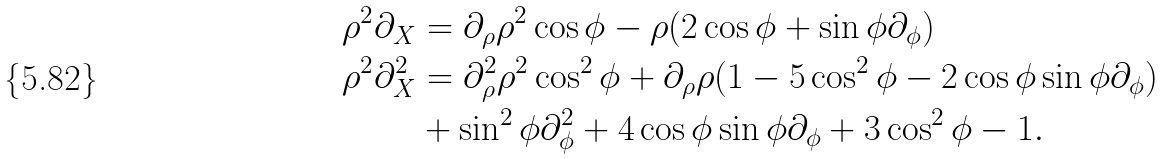<formula> <loc_0><loc_0><loc_500><loc_500>\rho ^ { 2 } \partial _ { X } & = \partial _ { \rho } \rho ^ { 2 } \cos \phi - \rho ( 2 \cos \phi + \sin \phi \partial _ { \phi } ) \\ \rho ^ { 2 } \partial ^ { 2 } _ { X } & = \partial _ { \rho } ^ { 2 } \rho ^ { 2 } \cos ^ { 2 } \phi + \partial _ { \rho } \rho ( 1 - 5 \cos ^ { 2 } \phi - 2 \cos \phi \sin \phi \partial _ { \phi } ) \\ & + \sin ^ { 2 } \phi \partial _ { \phi } ^ { 2 } + 4 \cos \phi \sin \phi \partial _ { \phi } + 3 \cos ^ { 2 } \phi - 1 .</formula> 